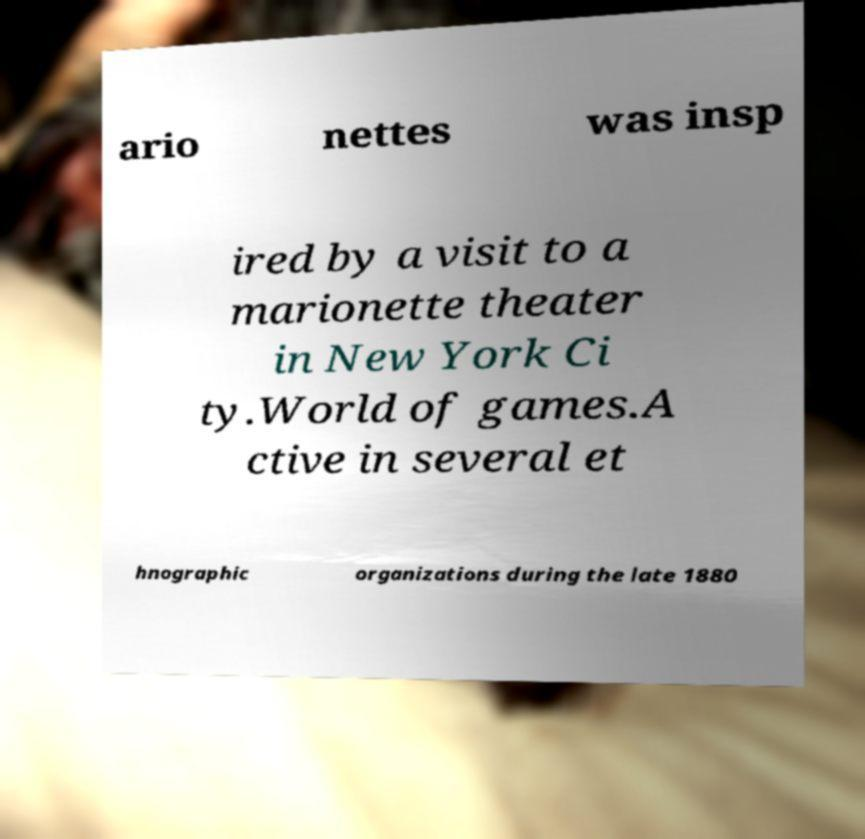Can you read and provide the text displayed in the image?This photo seems to have some interesting text. Can you extract and type it out for me? ario nettes was insp ired by a visit to a marionette theater in New York Ci ty.World of games.A ctive in several et hnographic organizations during the late 1880 